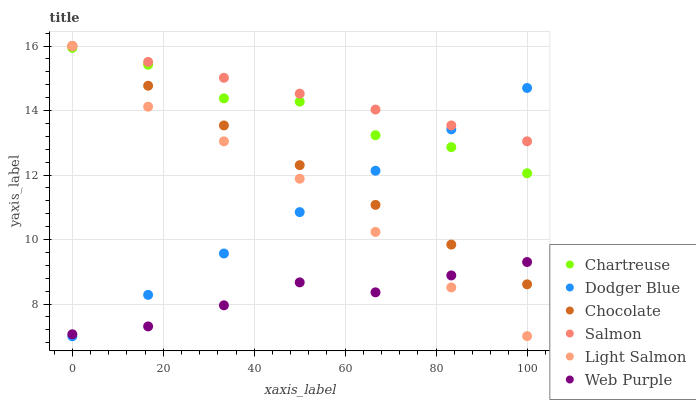Does Web Purple have the minimum area under the curve?
Answer yes or no. Yes. Does Salmon have the maximum area under the curve?
Answer yes or no. Yes. Does Salmon have the minimum area under the curve?
Answer yes or no. No. Does Web Purple have the maximum area under the curve?
Answer yes or no. No. Is Salmon the smoothest?
Answer yes or no. Yes. Is Chartreuse the roughest?
Answer yes or no. Yes. Is Web Purple the smoothest?
Answer yes or no. No. Is Web Purple the roughest?
Answer yes or no. No. Does Dodger Blue have the lowest value?
Answer yes or no. Yes. Does Web Purple have the lowest value?
Answer yes or no. No. Does Chocolate have the highest value?
Answer yes or no. Yes. Does Web Purple have the highest value?
Answer yes or no. No. Is Chartreuse less than Salmon?
Answer yes or no. Yes. Is Chartreuse greater than Web Purple?
Answer yes or no. Yes. Does Chocolate intersect Web Purple?
Answer yes or no. Yes. Is Chocolate less than Web Purple?
Answer yes or no. No. Is Chocolate greater than Web Purple?
Answer yes or no. No. Does Chartreuse intersect Salmon?
Answer yes or no. No. 